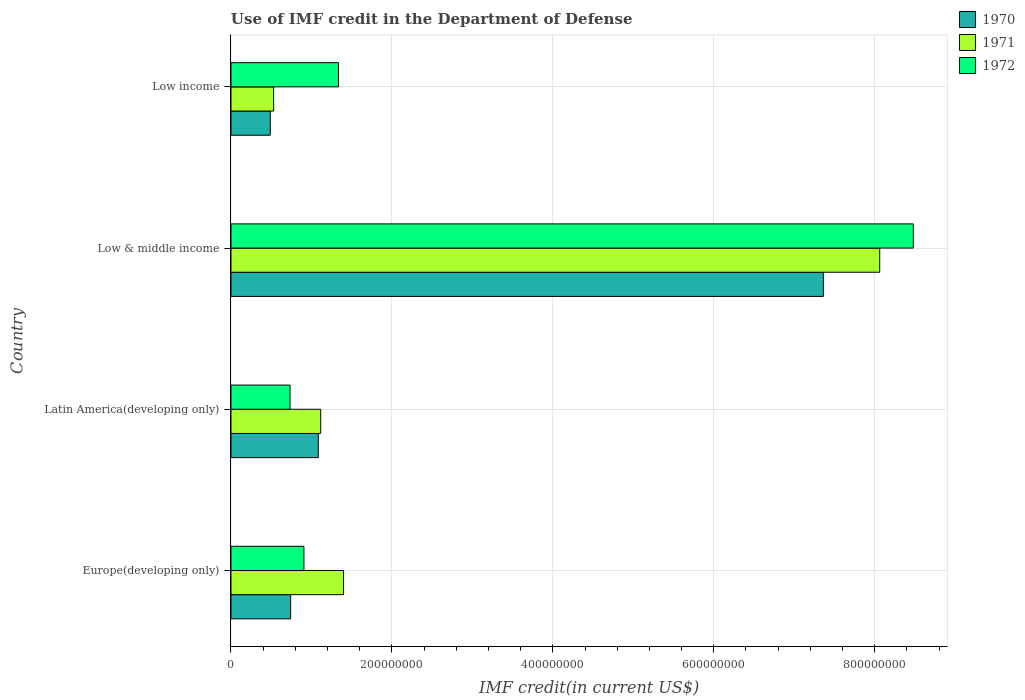Are the number of bars on each tick of the Y-axis equal?
Your response must be concise. Yes. How many bars are there on the 3rd tick from the top?
Make the answer very short. 3. How many bars are there on the 3rd tick from the bottom?
Provide a short and direct response. 3. What is the label of the 2nd group of bars from the top?
Provide a short and direct response. Low & middle income. In how many cases, is the number of bars for a given country not equal to the number of legend labels?
Keep it short and to the point. 0. What is the IMF credit in the Department of Defense in 1971 in Europe(developing only)?
Provide a short and direct response. 1.40e+08. Across all countries, what is the maximum IMF credit in the Department of Defense in 1971?
Make the answer very short. 8.06e+08. Across all countries, what is the minimum IMF credit in the Department of Defense in 1972?
Your answer should be very brief. 7.34e+07. What is the total IMF credit in the Department of Defense in 1971 in the graph?
Keep it short and to the point. 1.11e+09. What is the difference between the IMF credit in the Department of Defense in 1971 in Latin America(developing only) and that in Low income?
Provide a short and direct response. 5.85e+07. What is the difference between the IMF credit in the Department of Defense in 1972 in Europe(developing only) and the IMF credit in the Department of Defense in 1971 in Low & middle income?
Your answer should be compact. -7.16e+08. What is the average IMF credit in the Department of Defense in 1971 per country?
Make the answer very short. 2.78e+08. What is the difference between the IMF credit in the Department of Defense in 1971 and IMF credit in the Department of Defense in 1970 in Low income?
Provide a short and direct response. 4.21e+06. What is the ratio of the IMF credit in the Department of Defense in 1970 in Europe(developing only) to that in Low & middle income?
Ensure brevity in your answer.  0.1. Is the difference between the IMF credit in the Department of Defense in 1971 in Europe(developing only) and Low & middle income greater than the difference between the IMF credit in the Department of Defense in 1970 in Europe(developing only) and Low & middle income?
Give a very brief answer. No. What is the difference between the highest and the second highest IMF credit in the Department of Defense in 1971?
Provide a short and direct response. 6.66e+08. What is the difference between the highest and the lowest IMF credit in the Department of Defense in 1970?
Provide a short and direct response. 6.87e+08. In how many countries, is the IMF credit in the Department of Defense in 1970 greater than the average IMF credit in the Department of Defense in 1970 taken over all countries?
Make the answer very short. 1. What does the 1st bar from the bottom in Low income represents?
Offer a very short reply. 1970. Are all the bars in the graph horizontal?
Give a very brief answer. Yes. How many countries are there in the graph?
Offer a very short reply. 4. Are the values on the major ticks of X-axis written in scientific E-notation?
Your answer should be compact. No. Does the graph contain any zero values?
Provide a succinct answer. No. How many legend labels are there?
Provide a short and direct response. 3. How are the legend labels stacked?
Your answer should be compact. Vertical. What is the title of the graph?
Give a very brief answer. Use of IMF credit in the Department of Defense. What is the label or title of the X-axis?
Give a very brief answer. IMF credit(in current US$). What is the label or title of the Y-axis?
Your answer should be compact. Country. What is the IMF credit(in current US$) of 1970 in Europe(developing only)?
Ensure brevity in your answer.  7.41e+07. What is the IMF credit(in current US$) in 1971 in Europe(developing only)?
Offer a very short reply. 1.40e+08. What is the IMF credit(in current US$) in 1972 in Europe(developing only)?
Your response must be concise. 9.07e+07. What is the IMF credit(in current US$) in 1970 in Latin America(developing only)?
Your response must be concise. 1.09e+08. What is the IMF credit(in current US$) in 1971 in Latin America(developing only)?
Your answer should be very brief. 1.12e+08. What is the IMF credit(in current US$) of 1972 in Latin America(developing only)?
Make the answer very short. 7.34e+07. What is the IMF credit(in current US$) in 1970 in Low & middle income?
Your answer should be compact. 7.36e+08. What is the IMF credit(in current US$) of 1971 in Low & middle income?
Provide a short and direct response. 8.06e+08. What is the IMF credit(in current US$) in 1972 in Low & middle income?
Your response must be concise. 8.48e+08. What is the IMF credit(in current US$) in 1970 in Low income?
Keep it short and to the point. 4.88e+07. What is the IMF credit(in current US$) in 1971 in Low income?
Your response must be concise. 5.30e+07. What is the IMF credit(in current US$) of 1972 in Low income?
Make the answer very short. 1.34e+08. Across all countries, what is the maximum IMF credit(in current US$) in 1970?
Provide a succinct answer. 7.36e+08. Across all countries, what is the maximum IMF credit(in current US$) of 1971?
Give a very brief answer. 8.06e+08. Across all countries, what is the maximum IMF credit(in current US$) of 1972?
Provide a short and direct response. 8.48e+08. Across all countries, what is the minimum IMF credit(in current US$) of 1970?
Your response must be concise. 4.88e+07. Across all countries, what is the minimum IMF credit(in current US$) of 1971?
Ensure brevity in your answer.  5.30e+07. Across all countries, what is the minimum IMF credit(in current US$) in 1972?
Offer a very short reply. 7.34e+07. What is the total IMF credit(in current US$) of 1970 in the graph?
Ensure brevity in your answer.  9.68e+08. What is the total IMF credit(in current US$) in 1971 in the graph?
Offer a very short reply. 1.11e+09. What is the total IMF credit(in current US$) of 1972 in the graph?
Offer a terse response. 1.15e+09. What is the difference between the IMF credit(in current US$) in 1970 in Europe(developing only) and that in Latin America(developing only)?
Your answer should be very brief. -3.44e+07. What is the difference between the IMF credit(in current US$) in 1971 in Europe(developing only) and that in Latin America(developing only)?
Your answer should be very brief. 2.84e+07. What is the difference between the IMF credit(in current US$) in 1972 in Europe(developing only) and that in Latin America(developing only)?
Your answer should be compact. 1.72e+07. What is the difference between the IMF credit(in current US$) of 1970 in Europe(developing only) and that in Low & middle income?
Give a very brief answer. -6.62e+08. What is the difference between the IMF credit(in current US$) in 1971 in Europe(developing only) and that in Low & middle income?
Keep it short and to the point. -6.66e+08. What is the difference between the IMF credit(in current US$) in 1972 in Europe(developing only) and that in Low & middle income?
Your answer should be very brief. -7.57e+08. What is the difference between the IMF credit(in current US$) in 1970 in Europe(developing only) and that in Low income?
Ensure brevity in your answer.  2.53e+07. What is the difference between the IMF credit(in current US$) in 1971 in Europe(developing only) and that in Low income?
Offer a terse response. 8.69e+07. What is the difference between the IMF credit(in current US$) of 1972 in Europe(developing only) and that in Low income?
Your response must be concise. -4.29e+07. What is the difference between the IMF credit(in current US$) of 1970 in Latin America(developing only) and that in Low & middle income?
Provide a short and direct response. -6.28e+08. What is the difference between the IMF credit(in current US$) of 1971 in Latin America(developing only) and that in Low & middle income?
Ensure brevity in your answer.  -6.95e+08. What is the difference between the IMF credit(in current US$) in 1972 in Latin America(developing only) and that in Low & middle income?
Your response must be concise. -7.75e+08. What is the difference between the IMF credit(in current US$) of 1970 in Latin America(developing only) and that in Low income?
Offer a very short reply. 5.97e+07. What is the difference between the IMF credit(in current US$) in 1971 in Latin America(developing only) and that in Low income?
Offer a terse response. 5.85e+07. What is the difference between the IMF credit(in current US$) in 1972 in Latin America(developing only) and that in Low income?
Give a very brief answer. -6.01e+07. What is the difference between the IMF credit(in current US$) in 1970 in Low & middle income and that in Low income?
Give a very brief answer. 6.87e+08. What is the difference between the IMF credit(in current US$) of 1971 in Low & middle income and that in Low income?
Keep it short and to the point. 7.53e+08. What is the difference between the IMF credit(in current US$) in 1972 in Low & middle income and that in Low income?
Keep it short and to the point. 7.14e+08. What is the difference between the IMF credit(in current US$) in 1970 in Europe(developing only) and the IMF credit(in current US$) in 1971 in Latin America(developing only)?
Offer a terse response. -3.74e+07. What is the difference between the IMF credit(in current US$) in 1970 in Europe(developing only) and the IMF credit(in current US$) in 1972 in Latin America(developing only)?
Keep it short and to the point. 7.05e+05. What is the difference between the IMF credit(in current US$) in 1971 in Europe(developing only) and the IMF credit(in current US$) in 1972 in Latin America(developing only)?
Keep it short and to the point. 6.65e+07. What is the difference between the IMF credit(in current US$) in 1970 in Europe(developing only) and the IMF credit(in current US$) in 1971 in Low & middle income?
Your answer should be compact. -7.32e+08. What is the difference between the IMF credit(in current US$) of 1970 in Europe(developing only) and the IMF credit(in current US$) of 1972 in Low & middle income?
Offer a terse response. -7.74e+08. What is the difference between the IMF credit(in current US$) in 1971 in Europe(developing only) and the IMF credit(in current US$) in 1972 in Low & middle income?
Your answer should be compact. -7.08e+08. What is the difference between the IMF credit(in current US$) of 1970 in Europe(developing only) and the IMF credit(in current US$) of 1971 in Low income?
Provide a short and direct response. 2.11e+07. What is the difference between the IMF credit(in current US$) of 1970 in Europe(developing only) and the IMF credit(in current US$) of 1972 in Low income?
Your response must be concise. -5.94e+07. What is the difference between the IMF credit(in current US$) in 1971 in Europe(developing only) and the IMF credit(in current US$) in 1972 in Low income?
Provide a short and direct response. 6.35e+06. What is the difference between the IMF credit(in current US$) of 1970 in Latin America(developing only) and the IMF credit(in current US$) of 1971 in Low & middle income?
Your response must be concise. -6.98e+08. What is the difference between the IMF credit(in current US$) of 1970 in Latin America(developing only) and the IMF credit(in current US$) of 1972 in Low & middle income?
Offer a very short reply. -7.40e+08. What is the difference between the IMF credit(in current US$) of 1971 in Latin America(developing only) and the IMF credit(in current US$) of 1972 in Low & middle income?
Ensure brevity in your answer.  -7.37e+08. What is the difference between the IMF credit(in current US$) in 1970 in Latin America(developing only) and the IMF credit(in current US$) in 1971 in Low income?
Your answer should be compact. 5.55e+07. What is the difference between the IMF credit(in current US$) of 1970 in Latin America(developing only) and the IMF credit(in current US$) of 1972 in Low income?
Give a very brief answer. -2.50e+07. What is the difference between the IMF credit(in current US$) in 1971 in Latin America(developing only) and the IMF credit(in current US$) in 1972 in Low income?
Your response must be concise. -2.20e+07. What is the difference between the IMF credit(in current US$) in 1970 in Low & middle income and the IMF credit(in current US$) in 1971 in Low income?
Offer a very short reply. 6.83e+08. What is the difference between the IMF credit(in current US$) of 1970 in Low & middle income and the IMF credit(in current US$) of 1972 in Low income?
Ensure brevity in your answer.  6.03e+08. What is the difference between the IMF credit(in current US$) in 1971 in Low & middle income and the IMF credit(in current US$) in 1972 in Low income?
Ensure brevity in your answer.  6.73e+08. What is the average IMF credit(in current US$) in 1970 per country?
Offer a very short reply. 2.42e+08. What is the average IMF credit(in current US$) of 1971 per country?
Offer a very short reply. 2.78e+08. What is the average IMF credit(in current US$) in 1972 per country?
Make the answer very short. 2.86e+08. What is the difference between the IMF credit(in current US$) of 1970 and IMF credit(in current US$) of 1971 in Europe(developing only)?
Your answer should be compact. -6.58e+07. What is the difference between the IMF credit(in current US$) of 1970 and IMF credit(in current US$) of 1972 in Europe(developing only)?
Your response must be concise. -1.65e+07. What is the difference between the IMF credit(in current US$) in 1971 and IMF credit(in current US$) in 1972 in Europe(developing only)?
Offer a terse response. 4.93e+07. What is the difference between the IMF credit(in current US$) in 1970 and IMF credit(in current US$) in 1971 in Latin America(developing only)?
Keep it short and to the point. -3.01e+06. What is the difference between the IMF credit(in current US$) in 1970 and IMF credit(in current US$) in 1972 in Latin America(developing only)?
Offer a terse response. 3.51e+07. What is the difference between the IMF credit(in current US$) of 1971 and IMF credit(in current US$) of 1972 in Latin America(developing only)?
Provide a succinct answer. 3.81e+07. What is the difference between the IMF credit(in current US$) of 1970 and IMF credit(in current US$) of 1971 in Low & middle income?
Your answer should be very brief. -7.00e+07. What is the difference between the IMF credit(in current US$) in 1970 and IMF credit(in current US$) in 1972 in Low & middle income?
Provide a succinct answer. -1.12e+08. What is the difference between the IMF credit(in current US$) in 1971 and IMF credit(in current US$) in 1972 in Low & middle income?
Provide a succinct answer. -4.18e+07. What is the difference between the IMF credit(in current US$) of 1970 and IMF credit(in current US$) of 1971 in Low income?
Offer a very short reply. -4.21e+06. What is the difference between the IMF credit(in current US$) in 1970 and IMF credit(in current US$) in 1972 in Low income?
Ensure brevity in your answer.  -8.47e+07. What is the difference between the IMF credit(in current US$) of 1971 and IMF credit(in current US$) of 1972 in Low income?
Give a very brief answer. -8.05e+07. What is the ratio of the IMF credit(in current US$) in 1970 in Europe(developing only) to that in Latin America(developing only)?
Offer a terse response. 0.68. What is the ratio of the IMF credit(in current US$) of 1971 in Europe(developing only) to that in Latin America(developing only)?
Offer a very short reply. 1.25. What is the ratio of the IMF credit(in current US$) of 1972 in Europe(developing only) to that in Latin America(developing only)?
Ensure brevity in your answer.  1.23. What is the ratio of the IMF credit(in current US$) in 1970 in Europe(developing only) to that in Low & middle income?
Ensure brevity in your answer.  0.1. What is the ratio of the IMF credit(in current US$) of 1971 in Europe(developing only) to that in Low & middle income?
Your response must be concise. 0.17. What is the ratio of the IMF credit(in current US$) in 1972 in Europe(developing only) to that in Low & middle income?
Ensure brevity in your answer.  0.11. What is the ratio of the IMF credit(in current US$) in 1970 in Europe(developing only) to that in Low income?
Give a very brief answer. 1.52. What is the ratio of the IMF credit(in current US$) in 1971 in Europe(developing only) to that in Low income?
Your response must be concise. 2.64. What is the ratio of the IMF credit(in current US$) in 1972 in Europe(developing only) to that in Low income?
Keep it short and to the point. 0.68. What is the ratio of the IMF credit(in current US$) in 1970 in Latin America(developing only) to that in Low & middle income?
Your response must be concise. 0.15. What is the ratio of the IMF credit(in current US$) of 1971 in Latin America(developing only) to that in Low & middle income?
Ensure brevity in your answer.  0.14. What is the ratio of the IMF credit(in current US$) of 1972 in Latin America(developing only) to that in Low & middle income?
Provide a succinct answer. 0.09. What is the ratio of the IMF credit(in current US$) in 1970 in Latin America(developing only) to that in Low income?
Make the answer very short. 2.22. What is the ratio of the IMF credit(in current US$) of 1971 in Latin America(developing only) to that in Low income?
Your response must be concise. 2.1. What is the ratio of the IMF credit(in current US$) of 1972 in Latin America(developing only) to that in Low income?
Your answer should be very brief. 0.55. What is the ratio of the IMF credit(in current US$) of 1970 in Low & middle income to that in Low income?
Ensure brevity in your answer.  15.08. What is the ratio of the IMF credit(in current US$) of 1971 in Low & middle income to that in Low income?
Give a very brief answer. 15.21. What is the ratio of the IMF credit(in current US$) in 1972 in Low & middle income to that in Low income?
Keep it short and to the point. 6.35. What is the difference between the highest and the second highest IMF credit(in current US$) in 1970?
Keep it short and to the point. 6.28e+08. What is the difference between the highest and the second highest IMF credit(in current US$) of 1971?
Give a very brief answer. 6.66e+08. What is the difference between the highest and the second highest IMF credit(in current US$) of 1972?
Give a very brief answer. 7.14e+08. What is the difference between the highest and the lowest IMF credit(in current US$) in 1970?
Ensure brevity in your answer.  6.87e+08. What is the difference between the highest and the lowest IMF credit(in current US$) in 1971?
Your answer should be very brief. 7.53e+08. What is the difference between the highest and the lowest IMF credit(in current US$) in 1972?
Give a very brief answer. 7.75e+08. 